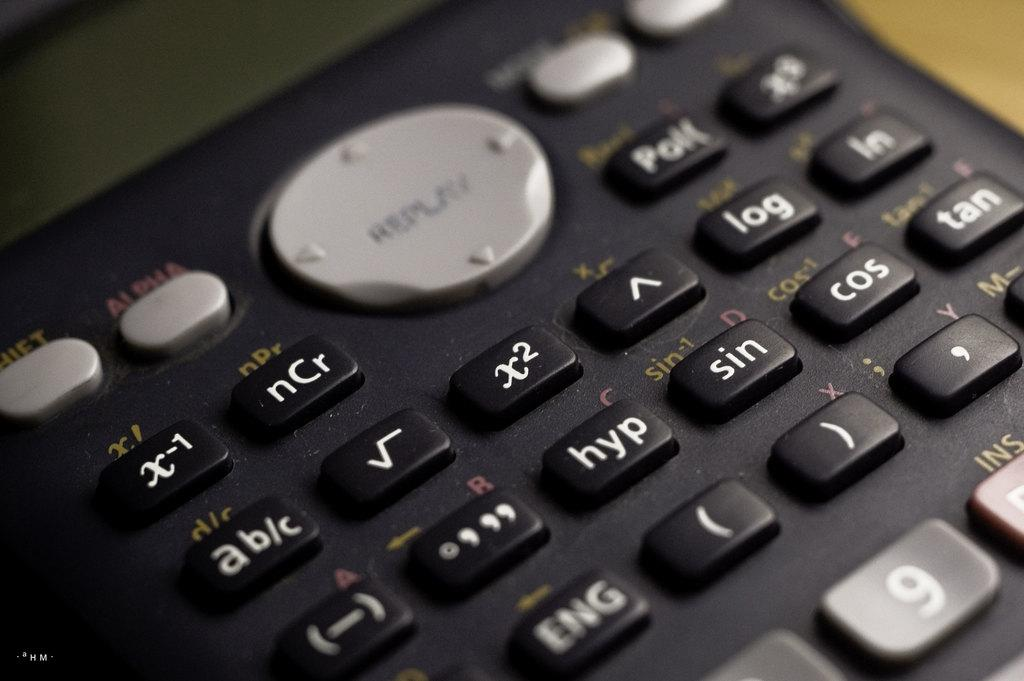<image>
Write a terse but informative summary of the picture. The Replay button is clearly visible on a calculator. 